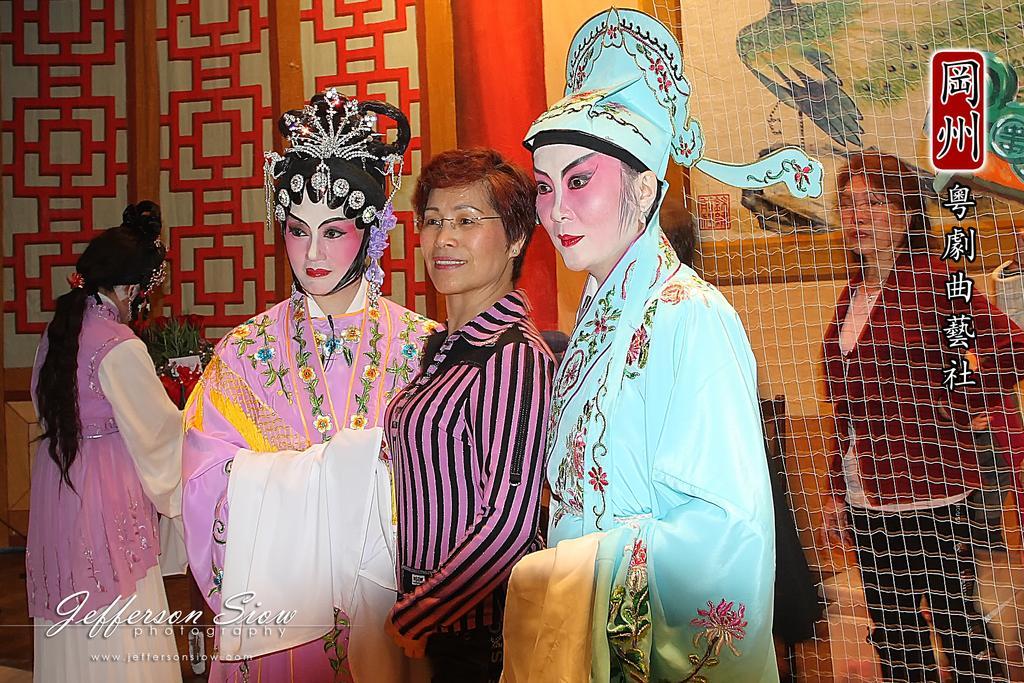Can you describe this image briefly? This picture shows human standing and we see painting on their faces and we see a net and woman standing on the back. she wore spectacles on her face and we see a frame on the wall and we see text at the bottom of the picture. 